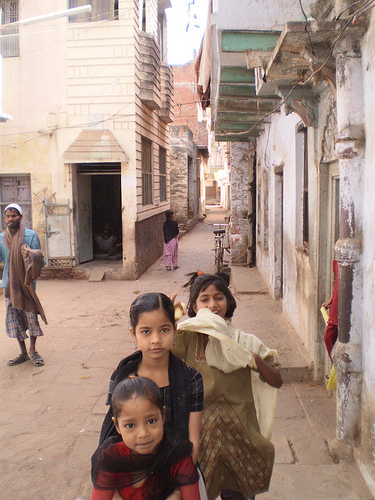<image>
Is there a girl behind the girl? Yes. From this viewpoint, the girl is positioned behind the girl, with the girl partially or fully occluding the girl. Is there a door next to the man? No. The door is not positioned next to the man. They are located in different areas of the scene. 